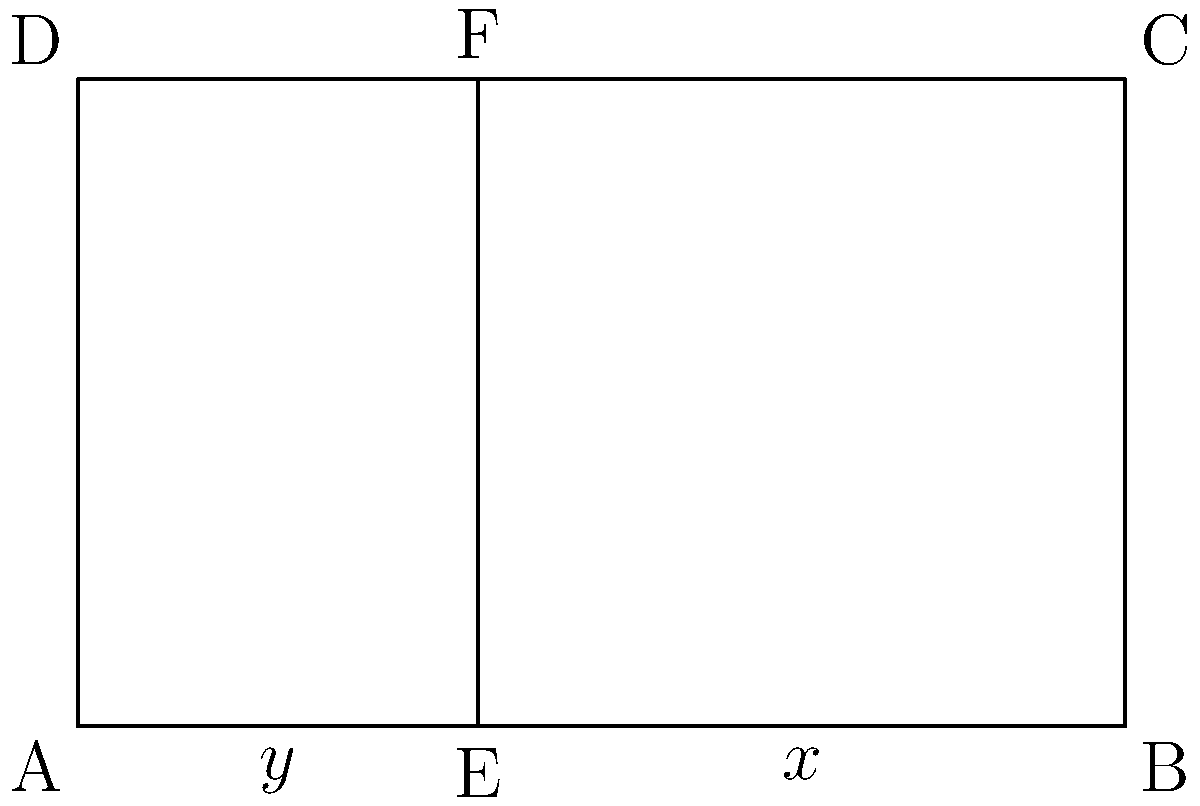In framing a shot for maximum aesthetic appeal, you decide to use the golden ratio. The frame is represented by rectangle ABCD, with a vertical line EF dividing it. If the width of the entire frame is 10 units and the height is 6.18 units, what is the length of AE (represented by y) to achieve the golden ratio in the composition? To solve this problem, we'll use the properties of the golden ratio and the given dimensions of the frame. Let's approach this step-by-step:

1) The golden ratio is approximately 1.618 or its reciprocal, 0.618.

2) In a composition following the golden ratio, the ratio of the smaller part to the larger part is equal to the ratio of the larger part to the whole.

3) Let's denote:
   - The width of the entire frame (AB) as 10 units
   - The height of the frame (AD) as 6.18 units
   - The smaller width (AE) as y
   - The larger width (EB) as x

4) We know that x + y = 10 (the total width)

5) According to the golden ratio principle:
   $$\frac{y}{x} = \frac{x}{10}$$

6) We can rewrite this as:
   $$y = \frac{x^2}{10}$$

7) Substituting this into the equation from step 4:
   $$\frac{x^2}{10} + x = 10$$

8) Multiplying both sides by 10:
   $$x^2 + 10x - 100 = 0$$

9) This is a quadratic equation. We can solve it using the quadratic formula:
   $$x = \frac{-b \pm \sqrt{b^2 - 4ac}}{2a}$$
   where a = 1, b = 10, and c = -100

10) Solving this:
    $$x = \frac{-10 \pm \sqrt{100 + 400}}{2} = \frac{-10 \pm \sqrt{500}}{2} = \frac{-10 \pm 22.36}{2}$$

11) Taking the positive solution:
    $$x = \frac{-10 + 22.36}{2} = 6.18$$

12) Therefore, y (AE) = 10 - 6.18 = 3.82 units

Thus, to achieve the golden ratio in the composition, the length of AE should be 3.82 units.
Answer: 3.82 units 